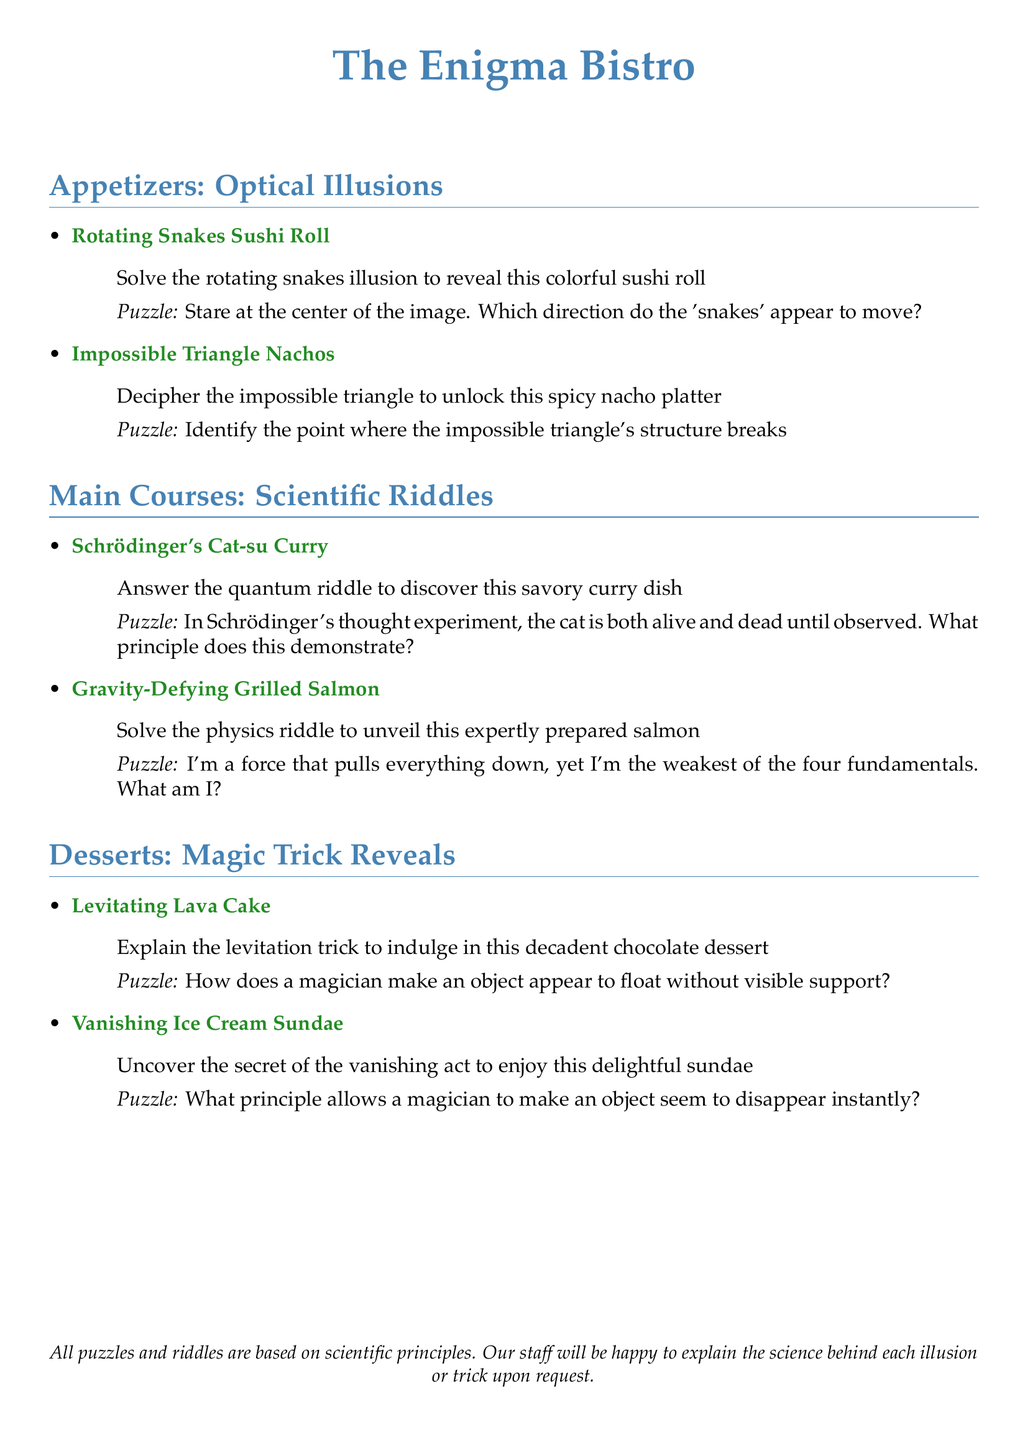What is the name of the appetizer featuring sushi? The appetizer featuring sushi is listed as the "Rotating Snakes Sushi Roll."
Answer: Rotating Snakes Sushi Roll What principle does Schrödinger's thought experiment demonstrate? The principle demonstrated is that the cat is both alive and dead until observed.
Answer: quantum superposition What dessert is associated with levitation? The dessert associated with levitation is the "Levitating Lava Cake."
Answer: Levitating Lava Cake What riddle must be solved for the Gravity-Defying Grilled Salmon? The riddle that must be solved is about a force that pulls everything down.
Answer: Gravity Identify the dish that requires deciphering an impossible triangle. The dish that requires deciphering an impossible triangle is "Impossible Triangle Nachos."
Answer: Impossible Triangle Nachos What does the menu encourage guests to do regarding the puzzles? The menu encourages guests to engage with the puzzles based on scientific principles.
Answer: solve challenges Which dessert involves a vanishing act? The dessert that involves a vanishing act is the "Vanishing Ice Cream Sundae."
Answer: Vanishing Ice Cream Sundae What color represents the dish names on the menu? The dish names on the menu are represented in the color green.
Answer: green What type of science does the menu emphasize? The menu emphasizes scientific principles related to illusions and magic tricks.
Answer: science 